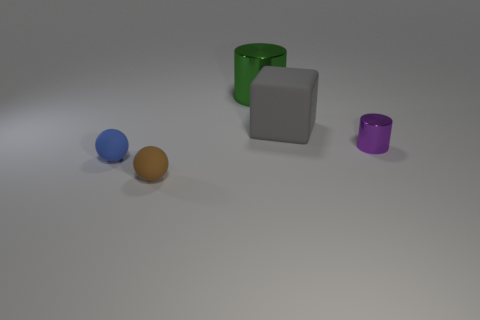What number of matte cubes are there?
Provide a short and direct response. 1. Do the rubber thing behind the blue ball and the blue matte sphere have the same size?
Make the answer very short. No. What number of metal things are either cylinders or yellow cylinders?
Provide a short and direct response. 2. How many gray objects are on the left side of the big cylinder to the left of the block?
Ensure brevity in your answer.  0. There is a object that is both left of the rubber cube and on the right side of the tiny brown matte object; what shape is it?
Your answer should be compact. Cylinder. What is the material of the tiny blue object that is left of the matte object right of the cylinder that is behind the small purple shiny cylinder?
Make the answer very short. Rubber. What material is the brown ball?
Your answer should be very brief. Rubber. Does the gray object have the same material as the tiny thing to the right of the small brown ball?
Give a very brief answer. No. There is a large thing that is right of the large thing that is left of the large gray block; what color is it?
Provide a succinct answer. Gray. There is a object that is both behind the small brown rubber sphere and in front of the small purple cylinder; how big is it?
Your response must be concise. Small. 